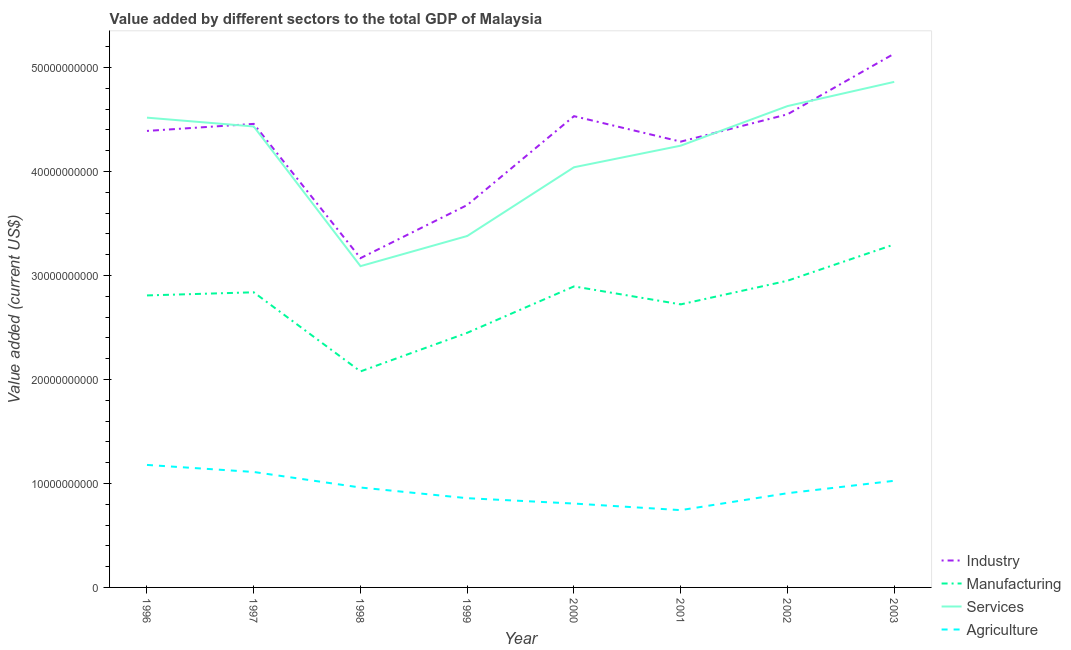Does the line corresponding to value added by industrial sector intersect with the line corresponding to value added by agricultural sector?
Offer a terse response. No. What is the value added by agricultural sector in 2002?
Keep it short and to the point. 9.06e+09. Across all years, what is the maximum value added by services sector?
Give a very brief answer. 4.86e+1. Across all years, what is the minimum value added by services sector?
Your response must be concise. 3.09e+1. In which year was the value added by services sector minimum?
Make the answer very short. 1998. What is the total value added by industrial sector in the graph?
Keep it short and to the point. 3.42e+11. What is the difference between the value added by industrial sector in 1997 and that in 2000?
Your answer should be compact. -7.43e+08. What is the difference between the value added by agricultural sector in 2002 and the value added by services sector in 1997?
Your answer should be very brief. -3.53e+1. What is the average value added by manufacturing sector per year?
Ensure brevity in your answer.  2.75e+1. In the year 1997, what is the difference between the value added by industrial sector and value added by manufacturing sector?
Make the answer very short. 1.62e+1. In how many years, is the value added by agricultural sector greater than 28000000000 US$?
Offer a very short reply. 0. What is the ratio of the value added by agricultural sector in 2000 to that in 2002?
Provide a short and direct response. 0.89. Is the value added by manufacturing sector in 1999 less than that in 2000?
Your answer should be compact. Yes. Is the difference between the value added by industrial sector in 2000 and 2001 greater than the difference between the value added by agricultural sector in 2000 and 2001?
Provide a succinct answer. Yes. What is the difference between the highest and the second highest value added by manufacturing sector?
Give a very brief answer. 3.49e+09. What is the difference between the highest and the lowest value added by industrial sector?
Ensure brevity in your answer.  1.97e+1. In how many years, is the value added by agricultural sector greater than the average value added by agricultural sector taken over all years?
Offer a very short reply. 4. Does the value added by industrial sector monotonically increase over the years?
Ensure brevity in your answer.  No. Is the value added by manufacturing sector strictly less than the value added by services sector over the years?
Your answer should be compact. Yes. How many years are there in the graph?
Make the answer very short. 8. Are the values on the major ticks of Y-axis written in scientific E-notation?
Offer a very short reply. No. Does the graph contain any zero values?
Your answer should be very brief. No. Where does the legend appear in the graph?
Give a very brief answer. Bottom right. How are the legend labels stacked?
Offer a terse response. Vertical. What is the title of the graph?
Your answer should be compact. Value added by different sectors to the total GDP of Malaysia. What is the label or title of the X-axis?
Offer a terse response. Year. What is the label or title of the Y-axis?
Your answer should be very brief. Value added (current US$). What is the Value added (current US$) in Industry in 1996?
Ensure brevity in your answer.  4.39e+1. What is the Value added (current US$) in Manufacturing in 1996?
Your answer should be very brief. 2.81e+1. What is the Value added (current US$) in Services in 1996?
Give a very brief answer. 4.52e+1. What is the Value added (current US$) of Agriculture in 1996?
Give a very brief answer. 1.18e+1. What is the Value added (current US$) of Industry in 1997?
Your answer should be compact. 4.46e+1. What is the Value added (current US$) in Manufacturing in 1997?
Offer a terse response. 2.84e+1. What is the Value added (current US$) in Services in 1997?
Provide a short and direct response. 4.43e+1. What is the Value added (current US$) of Agriculture in 1997?
Offer a very short reply. 1.11e+1. What is the Value added (current US$) in Industry in 1998?
Provide a succinct answer. 3.17e+1. What is the Value added (current US$) of Manufacturing in 1998?
Offer a terse response. 2.08e+1. What is the Value added (current US$) of Services in 1998?
Your answer should be compact. 3.09e+1. What is the Value added (current US$) in Agriculture in 1998?
Make the answer very short. 9.61e+09. What is the Value added (current US$) of Industry in 1999?
Make the answer very short. 3.68e+1. What is the Value added (current US$) of Manufacturing in 1999?
Make the answer very short. 2.45e+1. What is the Value added (current US$) of Services in 1999?
Your answer should be compact. 3.38e+1. What is the Value added (current US$) of Agriculture in 1999?
Offer a very short reply. 8.58e+09. What is the Value added (current US$) of Industry in 2000?
Offer a very short reply. 4.53e+1. What is the Value added (current US$) of Manufacturing in 2000?
Your answer should be very brief. 2.89e+1. What is the Value added (current US$) in Services in 2000?
Your answer should be very brief. 4.04e+1. What is the Value added (current US$) of Agriculture in 2000?
Your answer should be compact. 8.07e+09. What is the Value added (current US$) in Industry in 2001?
Give a very brief answer. 4.29e+1. What is the Value added (current US$) in Manufacturing in 2001?
Your answer should be very brief. 2.72e+1. What is the Value added (current US$) of Services in 2001?
Offer a terse response. 4.25e+1. What is the Value added (current US$) in Agriculture in 2001?
Make the answer very short. 7.43e+09. What is the Value added (current US$) of Industry in 2002?
Ensure brevity in your answer.  4.55e+1. What is the Value added (current US$) of Manufacturing in 2002?
Provide a short and direct response. 2.95e+1. What is the Value added (current US$) of Services in 2002?
Offer a very short reply. 4.63e+1. What is the Value added (current US$) in Agriculture in 2002?
Make the answer very short. 9.06e+09. What is the Value added (current US$) of Industry in 2003?
Provide a succinct answer. 5.13e+1. What is the Value added (current US$) in Manufacturing in 2003?
Your answer should be compact. 3.30e+1. What is the Value added (current US$) in Services in 2003?
Offer a very short reply. 4.86e+1. What is the Value added (current US$) of Agriculture in 2003?
Your answer should be compact. 1.03e+1. Across all years, what is the maximum Value added (current US$) of Industry?
Your response must be concise. 5.13e+1. Across all years, what is the maximum Value added (current US$) in Manufacturing?
Your response must be concise. 3.30e+1. Across all years, what is the maximum Value added (current US$) of Services?
Give a very brief answer. 4.86e+1. Across all years, what is the maximum Value added (current US$) in Agriculture?
Provide a succinct answer. 1.18e+1. Across all years, what is the minimum Value added (current US$) in Industry?
Make the answer very short. 3.17e+1. Across all years, what is the minimum Value added (current US$) in Manufacturing?
Ensure brevity in your answer.  2.08e+1. Across all years, what is the minimum Value added (current US$) in Services?
Your answer should be very brief. 3.09e+1. Across all years, what is the minimum Value added (current US$) of Agriculture?
Keep it short and to the point. 7.43e+09. What is the total Value added (current US$) of Industry in the graph?
Your response must be concise. 3.42e+11. What is the total Value added (current US$) of Manufacturing in the graph?
Keep it short and to the point. 2.20e+11. What is the total Value added (current US$) in Services in the graph?
Offer a very short reply. 3.32e+11. What is the total Value added (current US$) of Agriculture in the graph?
Keep it short and to the point. 7.59e+1. What is the difference between the Value added (current US$) of Industry in 1996 and that in 1997?
Your answer should be compact. -6.77e+08. What is the difference between the Value added (current US$) in Manufacturing in 1996 and that in 1997?
Offer a very short reply. -3.01e+08. What is the difference between the Value added (current US$) of Services in 1996 and that in 1997?
Make the answer very short. 8.48e+08. What is the difference between the Value added (current US$) in Agriculture in 1996 and that in 1997?
Make the answer very short. 6.78e+08. What is the difference between the Value added (current US$) in Industry in 1996 and that in 1998?
Your response must be concise. 1.22e+1. What is the difference between the Value added (current US$) of Manufacturing in 1996 and that in 1998?
Keep it short and to the point. 7.31e+09. What is the difference between the Value added (current US$) in Services in 1996 and that in 1998?
Your answer should be very brief. 1.43e+1. What is the difference between the Value added (current US$) in Agriculture in 1996 and that in 1998?
Offer a terse response. 2.17e+09. What is the difference between the Value added (current US$) of Industry in 1996 and that in 1999?
Offer a very short reply. 7.13e+09. What is the difference between the Value added (current US$) in Manufacturing in 1996 and that in 1999?
Your response must be concise. 3.60e+09. What is the difference between the Value added (current US$) of Services in 1996 and that in 1999?
Offer a terse response. 1.14e+1. What is the difference between the Value added (current US$) of Agriculture in 1996 and that in 1999?
Your answer should be very brief. 3.20e+09. What is the difference between the Value added (current US$) of Industry in 1996 and that in 2000?
Provide a succinct answer. -1.42e+09. What is the difference between the Value added (current US$) in Manufacturing in 1996 and that in 2000?
Ensure brevity in your answer.  -8.66e+08. What is the difference between the Value added (current US$) of Services in 1996 and that in 2000?
Make the answer very short. 4.77e+09. What is the difference between the Value added (current US$) of Agriculture in 1996 and that in 2000?
Offer a very short reply. 3.72e+09. What is the difference between the Value added (current US$) in Industry in 1996 and that in 2001?
Ensure brevity in your answer.  1.03e+09. What is the difference between the Value added (current US$) of Manufacturing in 1996 and that in 2001?
Your answer should be very brief. 8.61e+08. What is the difference between the Value added (current US$) in Services in 1996 and that in 2001?
Keep it short and to the point. 2.69e+09. What is the difference between the Value added (current US$) of Agriculture in 1996 and that in 2001?
Provide a succinct answer. 4.35e+09. What is the difference between the Value added (current US$) in Industry in 1996 and that in 2002?
Offer a terse response. -1.60e+09. What is the difference between the Value added (current US$) of Manufacturing in 1996 and that in 2002?
Your answer should be very brief. -1.41e+09. What is the difference between the Value added (current US$) in Services in 1996 and that in 2002?
Offer a terse response. -1.11e+09. What is the difference between the Value added (current US$) of Agriculture in 1996 and that in 2002?
Your response must be concise. 2.72e+09. What is the difference between the Value added (current US$) in Industry in 1996 and that in 2003?
Keep it short and to the point. -7.43e+09. What is the difference between the Value added (current US$) in Manufacturing in 1996 and that in 2003?
Your answer should be very brief. -4.90e+09. What is the difference between the Value added (current US$) of Services in 1996 and that in 2003?
Give a very brief answer. -3.44e+09. What is the difference between the Value added (current US$) in Agriculture in 1996 and that in 2003?
Offer a very short reply. 1.52e+09. What is the difference between the Value added (current US$) in Industry in 1997 and that in 1998?
Offer a very short reply. 1.29e+1. What is the difference between the Value added (current US$) of Manufacturing in 1997 and that in 1998?
Offer a very short reply. 7.61e+09. What is the difference between the Value added (current US$) of Services in 1997 and that in 1998?
Provide a succinct answer. 1.34e+1. What is the difference between the Value added (current US$) in Agriculture in 1997 and that in 1998?
Give a very brief answer. 1.49e+09. What is the difference between the Value added (current US$) in Industry in 1997 and that in 1999?
Give a very brief answer. 7.80e+09. What is the difference between the Value added (current US$) in Manufacturing in 1997 and that in 1999?
Offer a terse response. 3.90e+09. What is the difference between the Value added (current US$) of Services in 1997 and that in 1999?
Offer a terse response. 1.05e+1. What is the difference between the Value added (current US$) of Agriculture in 1997 and that in 1999?
Your answer should be compact. 2.52e+09. What is the difference between the Value added (current US$) of Industry in 1997 and that in 2000?
Make the answer very short. -7.43e+08. What is the difference between the Value added (current US$) of Manufacturing in 1997 and that in 2000?
Provide a succinct answer. -5.65e+08. What is the difference between the Value added (current US$) of Services in 1997 and that in 2000?
Your answer should be compact. 3.92e+09. What is the difference between the Value added (current US$) in Agriculture in 1997 and that in 2000?
Make the answer very short. 3.04e+09. What is the difference between the Value added (current US$) of Industry in 1997 and that in 2001?
Provide a succinct answer. 1.71e+09. What is the difference between the Value added (current US$) in Manufacturing in 1997 and that in 2001?
Offer a terse response. 1.16e+09. What is the difference between the Value added (current US$) of Services in 1997 and that in 2001?
Provide a short and direct response. 1.85e+09. What is the difference between the Value added (current US$) of Agriculture in 1997 and that in 2001?
Offer a terse response. 3.67e+09. What is the difference between the Value added (current US$) of Industry in 1997 and that in 2002?
Your answer should be compact. -9.21e+08. What is the difference between the Value added (current US$) in Manufacturing in 1997 and that in 2002?
Your answer should be compact. -1.11e+09. What is the difference between the Value added (current US$) of Services in 1997 and that in 2002?
Make the answer very short. -1.96e+09. What is the difference between the Value added (current US$) of Agriculture in 1997 and that in 2002?
Your response must be concise. 2.04e+09. What is the difference between the Value added (current US$) of Industry in 1997 and that in 2003?
Provide a short and direct response. -6.75e+09. What is the difference between the Value added (current US$) of Manufacturing in 1997 and that in 2003?
Keep it short and to the point. -4.60e+09. What is the difference between the Value added (current US$) of Services in 1997 and that in 2003?
Give a very brief answer. -4.29e+09. What is the difference between the Value added (current US$) in Agriculture in 1997 and that in 2003?
Your answer should be compact. 8.47e+08. What is the difference between the Value added (current US$) in Industry in 1998 and that in 1999?
Your answer should be very brief. -5.11e+09. What is the difference between the Value added (current US$) of Manufacturing in 1998 and that in 1999?
Your answer should be very brief. -3.71e+09. What is the difference between the Value added (current US$) of Services in 1998 and that in 1999?
Make the answer very short. -2.90e+09. What is the difference between the Value added (current US$) in Agriculture in 1998 and that in 1999?
Your answer should be very brief. 1.03e+09. What is the difference between the Value added (current US$) in Industry in 1998 and that in 2000?
Your answer should be compact. -1.37e+1. What is the difference between the Value added (current US$) of Manufacturing in 1998 and that in 2000?
Give a very brief answer. -8.18e+09. What is the difference between the Value added (current US$) of Services in 1998 and that in 2000?
Offer a terse response. -9.51e+09. What is the difference between the Value added (current US$) in Agriculture in 1998 and that in 2000?
Provide a short and direct response. 1.54e+09. What is the difference between the Value added (current US$) of Industry in 1998 and that in 2001?
Your response must be concise. -1.12e+1. What is the difference between the Value added (current US$) in Manufacturing in 1998 and that in 2001?
Your answer should be compact. -6.45e+09. What is the difference between the Value added (current US$) of Services in 1998 and that in 2001?
Give a very brief answer. -1.16e+1. What is the difference between the Value added (current US$) in Agriculture in 1998 and that in 2001?
Provide a short and direct response. 2.17e+09. What is the difference between the Value added (current US$) of Industry in 1998 and that in 2002?
Ensure brevity in your answer.  -1.38e+1. What is the difference between the Value added (current US$) in Manufacturing in 1998 and that in 2002?
Your response must be concise. -8.72e+09. What is the difference between the Value added (current US$) of Services in 1998 and that in 2002?
Provide a succinct answer. -1.54e+1. What is the difference between the Value added (current US$) in Agriculture in 1998 and that in 2002?
Give a very brief answer. 5.47e+08. What is the difference between the Value added (current US$) of Industry in 1998 and that in 2003?
Offer a terse response. -1.97e+1. What is the difference between the Value added (current US$) in Manufacturing in 1998 and that in 2003?
Offer a terse response. -1.22e+1. What is the difference between the Value added (current US$) of Services in 1998 and that in 2003?
Offer a very short reply. -1.77e+1. What is the difference between the Value added (current US$) of Agriculture in 1998 and that in 2003?
Your response must be concise. -6.48e+08. What is the difference between the Value added (current US$) in Industry in 1999 and that in 2000?
Ensure brevity in your answer.  -8.55e+09. What is the difference between the Value added (current US$) of Manufacturing in 1999 and that in 2000?
Give a very brief answer. -4.46e+09. What is the difference between the Value added (current US$) of Services in 1999 and that in 2000?
Offer a very short reply. -6.61e+09. What is the difference between the Value added (current US$) in Agriculture in 1999 and that in 2000?
Provide a short and direct response. 5.16e+08. What is the difference between the Value added (current US$) in Industry in 1999 and that in 2001?
Give a very brief answer. -6.10e+09. What is the difference between the Value added (current US$) of Manufacturing in 1999 and that in 2001?
Make the answer very short. -2.73e+09. What is the difference between the Value added (current US$) of Services in 1999 and that in 2001?
Keep it short and to the point. -8.69e+09. What is the difference between the Value added (current US$) of Agriculture in 1999 and that in 2001?
Provide a short and direct response. 1.15e+09. What is the difference between the Value added (current US$) of Industry in 1999 and that in 2002?
Offer a terse response. -8.72e+09. What is the difference between the Value added (current US$) of Manufacturing in 1999 and that in 2002?
Give a very brief answer. -5.01e+09. What is the difference between the Value added (current US$) of Services in 1999 and that in 2002?
Offer a very short reply. -1.25e+1. What is the difference between the Value added (current US$) of Agriculture in 1999 and that in 2002?
Your answer should be compact. -4.79e+08. What is the difference between the Value added (current US$) in Industry in 1999 and that in 2003?
Make the answer very short. -1.46e+1. What is the difference between the Value added (current US$) in Manufacturing in 1999 and that in 2003?
Provide a succinct answer. -8.50e+09. What is the difference between the Value added (current US$) in Services in 1999 and that in 2003?
Ensure brevity in your answer.  -1.48e+1. What is the difference between the Value added (current US$) of Agriculture in 1999 and that in 2003?
Provide a succinct answer. -1.67e+09. What is the difference between the Value added (current US$) of Industry in 2000 and that in 2001?
Keep it short and to the point. 2.45e+09. What is the difference between the Value added (current US$) in Manufacturing in 2000 and that in 2001?
Ensure brevity in your answer.  1.73e+09. What is the difference between the Value added (current US$) in Services in 2000 and that in 2001?
Provide a short and direct response. -2.08e+09. What is the difference between the Value added (current US$) in Agriculture in 2000 and that in 2001?
Offer a very short reply. 6.32e+08. What is the difference between the Value added (current US$) of Industry in 2000 and that in 2002?
Make the answer very short. -1.78e+08. What is the difference between the Value added (current US$) of Manufacturing in 2000 and that in 2002?
Your answer should be compact. -5.47e+08. What is the difference between the Value added (current US$) of Services in 2000 and that in 2002?
Offer a very short reply. -5.88e+09. What is the difference between the Value added (current US$) of Agriculture in 2000 and that in 2002?
Your answer should be very brief. -9.96e+08. What is the difference between the Value added (current US$) of Industry in 2000 and that in 2003?
Offer a terse response. -6.01e+09. What is the difference between the Value added (current US$) in Manufacturing in 2000 and that in 2003?
Provide a succinct answer. -4.04e+09. What is the difference between the Value added (current US$) in Services in 2000 and that in 2003?
Provide a short and direct response. -8.21e+09. What is the difference between the Value added (current US$) of Agriculture in 2000 and that in 2003?
Your answer should be compact. -2.19e+09. What is the difference between the Value added (current US$) in Industry in 2001 and that in 2002?
Your answer should be very brief. -2.63e+09. What is the difference between the Value added (current US$) in Manufacturing in 2001 and that in 2002?
Give a very brief answer. -2.27e+09. What is the difference between the Value added (current US$) of Services in 2001 and that in 2002?
Your answer should be very brief. -3.81e+09. What is the difference between the Value added (current US$) of Agriculture in 2001 and that in 2002?
Provide a succinct answer. -1.63e+09. What is the difference between the Value added (current US$) of Industry in 2001 and that in 2003?
Offer a terse response. -8.46e+09. What is the difference between the Value added (current US$) in Manufacturing in 2001 and that in 2003?
Your response must be concise. -5.76e+09. What is the difference between the Value added (current US$) of Services in 2001 and that in 2003?
Give a very brief answer. -6.13e+09. What is the difference between the Value added (current US$) of Agriculture in 2001 and that in 2003?
Make the answer very short. -2.82e+09. What is the difference between the Value added (current US$) of Industry in 2002 and that in 2003?
Your answer should be very brief. -5.83e+09. What is the difference between the Value added (current US$) in Manufacturing in 2002 and that in 2003?
Make the answer very short. -3.49e+09. What is the difference between the Value added (current US$) of Services in 2002 and that in 2003?
Keep it short and to the point. -2.33e+09. What is the difference between the Value added (current US$) of Agriculture in 2002 and that in 2003?
Offer a very short reply. -1.19e+09. What is the difference between the Value added (current US$) of Industry in 1996 and the Value added (current US$) of Manufacturing in 1997?
Your response must be concise. 1.55e+1. What is the difference between the Value added (current US$) of Industry in 1996 and the Value added (current US$) of Services in 1997?
Offer a very short reply. -4.28e+08. What is the difference between the Value added (current US$) of Industry in 1996 and the Value added (current US$) of Agriculture in 1997?
Keep it short and to the point. 3.28e+1. What is the difference between the Value added (current US$) of Manufacturing in 1996 and the Value added (current US$) of Services in 1997?
Give a very brief answer. -1.62e+1. What is the difference between the Value added (current US$) of Manufacturing in 1996 and the Value added (current US$) of Agriculture in 1997?
Your response must be concise. 1.70e+1. What is the difference between the Value added (current US$) of Services in 1996 and the Value added (current US$) of Agriculture in 1997?
Your answer should be very brief. 3.41e+1. What is the difference between the Value added (current US$) of Industry in 1996 and the Value added (current US$) of Manufacturing in 1998?
Provide a short and direct response. 2.31e+1. What is the difference between the Value added (current US$) in Industry in 1996 and the Value added (current US$) in Services in 1998?
Your response must be concise. 1.30e+1. What is the difference between the Value added (current US$) in Industry in 1996 and the Value added (current US$) in Agriculture in 1998?
Your response must be concise. 3.43e+1. What is the difference between the Value added (current US$) of Manufacturing in 1996 and the Value added (current US$) of Services in 1998?
Your answer should be very brief. -2.81e+09. What is the difference between the Value added (current US$) in Manufacturing in 1996 and the Value added (current US$) in Agriculture in 1998?
Give a very brief answer. 1.85e+1. What is the difference between the Value added (current US$) of Services in 1996 and the Value added (current US$) of Agriculture in 1998?
Your answer should be compact. 3.56e+1. What is the difference between the Value added (current US$) of Industry in 1996 and the Value added (current US$) of Manufacturing in 1999?
Your answer should be compact. 1.94e+1. What is the difference between the Value added (current US$) of Industry in 1996 and the Value added (current US$) of Services in 1999?
Your response must be concise. 1.01e+1. What is the difference between the Value added (current US$) of Industry in 1996 and the Value added (current US$) of Agriculture in 1999?
Your response must be concise. 3.53e+1. What is the difference between the Value added (current US$) in Manufacturing in 1996 and the Value added (current US$) in Services in 1999?
Give a very brief answer. -5.71e+09. What is the difference between the Value added (current US$) of Manufacturing in 1996 and the Value added (current US$) of Agriculture in 1999?
Offer a terse response. 1.95e+1. What is the difference between the Value added (current US$) in Services in 1996 and the Value added (current US$) in Agriculture in 1999?
Offer a terse response. 3.66e+1. What is the difference between the Value added (current US$) of Industry in 1996 and the Value added (current US$) of Manufacturing in 2000?
Your answer should be compact. 1.50e+1. What is the difference between the Value added (current US$) in Industry in 1996 and the Value added (current US$) in Services in 2000?
Your response must be concise. 3.49e+09. What is the difference between the Value added (current US$) of Industry in 1996 and the Value added (current US$) of Agriculture in 2000?
Give a very brief answer. 3.58e+1. What is the difference between the Value added (current US$) of Manufacturing in 1996 and the Value added (current US$) of Services in 2000?
Your response must be concise. -1.23e+1. What is the difference between the Value added (current US$) in Manufacturing in 1996 and the Value added (current US$) in Agriculture in 2000?
Give a very brief answer. 2.00e+1. What is the difference between the Value added (current US$) of Services in 1996 and the Value added (current US$) of Agriculture in 2000?
Keep it short and to the point. 3.71e+1. What is the difference between the Value added (current US$) in Industry in 1996 and the Value added (current US$) in Manufacturing in 2001?
Provide a succinct answer. 1.67e+1. What is the difference between the Value added (current US$) in Industry in 1996 and the Value added (current US$) in Services in 2001?
Keep it short and to the point. 1.42e+09. What is the difference between the Value added (current US$) in Industry in 1996 and the Value added (current US$) in Agriculture in 2001?
Your answer should be compact. 3.65e+1. What is the difference between the Value added (current US$) in Manufacturing in 1996 and the Value added (current US$) in Services in 2001?
Give a very brief answer. -1.44e+1. What is the difference between the Value added (current US$) in Manufacturing in 1996 and the Value added (current US$) in Agriculture in 2001?
Provide a succinct answer. 2.06e+1. What is the difference between the Value added (current US$) in Services in 1996 and the Value added (current US$) in Agriculture in 2001?
Offer a very short reply. 3.77e+1. What is the difference between the Value added (current US$) in Industry in 1996 and the Value added (current US$) in Manufacturing in 2002?
Provide a succinct answer. 1.44e+1. What is the difference between the Value added (current US$) of Industry in 1996 and the Value added (current US$) of Services in 2002?
Provide a short and direct response. -2.39e+09. What is the difference between the Value added (current US$) in Industry in 1996 and the Value added (current US$) in Agriculture in 2002?
Your response must be concise. 3.48e+1. What is the difference between the Value added (current US$) in Manufacturing in 1996 and the Value added (current US$) in Services in 2002?
Your answer should be very brief. -1.82e+1. What is the difference between the Value added (current US$) in Manufacturing in 1996 and the Value added (current US$) in Agriculture in 2002?
Give a very brief answer. 1.90e+1. What is the difference between the Value added (current US$) in Services in 1996 and the Value added (current US$) in Agriculture in 2002?
Your answer should be very brief. 3.61e+1. What is the difference between the Value added (current US$) of Industry in 1996 and the Value added (current US$) of Manufacturing in 2003?
Your response must be concise. 1.09e+1. What is the difference between the Value added (current US$) of Industry in 1996 and the Value added (current US$) of Services in 2003?
Your answer should be very brief. -4.72e+09. What is the difference between the Value added (current US$) in Industry in 1996 and the Value added (current US$) in Agriculture in 2003?
Offer a terse response. 3.36e+1. What is the difference between the Value added (current US$) of Manufacturing in 1996 and the Value added (current US$) of Services in 2003?
Make the answer very short. -2.05e+1. What is the difference between the Value added (current US$) in Manufacturing in 1996 and the Value added (current US$) in Agriculture in 2003?
Provide a succinct answer. 1.78e+1. What is the difference between the Value added (current US$) in Services in 1996 and the Value added (current US$) in Agriculture in 2003?
Your response must be concise. 3.49e+1. What is the difference between the Value added (current US$) of Industry in 1997 and the Value added (current US$) of Manufacturing in 1998?
Ensure brevity in your answer.  2.38e+1. What is the difference between the Value added (current US$) in Industry in 1997 and the Value added (current US$) in Services in 1998?
Provide a succinct answer. 1.37e+1. What is the difference between the Value added (current US$) in Industry in 1997 and the Value added (current US$) in Agriculture in 1998?
Ensure brevity in your answer.  3.50e+1. What is the difference between the Value added (current US$) of Manufacturing in 1997 and the Value added (current US$) of Services in 1998?
Keep it short and to the point. -2.51e+09. What is the difference between the Value added (current US$) in Manufacturing in 1997 and the Value added (current US$) in Agriculture in 1998?
Offer a terse response. 1.88e+1. What is the difference between the Value added (current US$) in Services in 1997 and the Value added (current US$) in Agriculture in 1998?
Ensure brevity in your answer.  3.47e+1. What is the difference between the Value added (current US$) of Industry in 1997 and the Value added (current US$) of Manufacturing in 1999?
Offer a very short reply. 2.01e+1. What is the difference between the Value added (current US$) of Industry in 1997 and the Value added (current US$) of Services in 1999?
Make the answer very short. 1.08e+1. What is the difference between the Value added (current US$) in Industry in 1997 and the Value added (current US$) in Agriculture in 1999?
Give a very brief answer. 3.60e+1. What is the difference between the Value added (current US$) in Manufacturing in 1997 and the Value added (current US$) in Services in 1999?
Make the answer very short. -5.41e+09. What is the difference between the Value added (current US$) in Manufacturing in 1997 and the Value added (current US$) in Agriculture in 1999?
Ensure brevity in your answer.  1.98e+1. What is the difference between the Value added (current US$) in Services in 1997 and the Value added (current US$) in Agriculture in 1999?
Your answer should be compact. 3.57e+1. What is the difference between the Value added (current US$) in Industry in 1997 and the Value added (current US$) in Manufacturing in 2000?
Your answer should be very brief. 1.56e+1. What is the difference between the Value added (current US$) of Industry in 1997 and the Value added (current US$) of Services in 2000?
Offer a terse response. 4.17e+09. What is the difference between the Value added (current US$) of Industry in 1997 and the Value added (current US$) of Agriculture in 2000?
Your response must be concise. 3.65e+1. What is the difference between the Value added (current US$) in Manufacturing in 1997 and the Value added (current US$) in Services in 2000?
Offer a terse response. -1.20e+1. What is the difference between the Value added (current US$) in Manufacturing in 1997 and the Value added (current US$) in Agriculture in 2000?
Your answer should be very brief. 2.03e+1. What is the difference between the Value added (current US$) in Services in 1997 and the Value added (current US$) in Agriculture in 2000?
Your response must be concise. 3.63e+1. What is the difference between the Value added (current US$) of Industry in 1997 and the Value added (current US$) of Manufacturing in 2001?
Keep it short and to the point. 1.74e+1. What is the difference between the Value added (current US$) in Industry in 1997 and the Value added (current US$) in Services in 2001?
Ensure brevity in your answer.  2.09e+09. What is the difference between the Value added (current US$) of Industry in 1997 and the Value added (current US$) of Agriculture in 2001?
Offer a terse response. 3.71e+1. What is the difference between the Value added (current US$) of Manufacturing in 1997 and the Value added (current US$) of Services in 2001?
Ensure brevity in your answer.  -1.41e+1. What is the difference between the Value added (current US$) of Manufacturing in 1997 and the Value added (current US$) of Agriculture in 2001?
Your response must be concise. 2.09e+1. What is the difference between the Value added (current US$) of Services in 1997 and the Value added (current US$) of Agriculture in 2001?
Offer a very short reply. 3.69e+1. What is the difference between the Value added (current US$) of Industry in 1997 and the Value added (current US$) of Manufacturing in 2002?
Provide a short and direct response. 1.51e+1. What is the difference between the Value added (current US$) in Industry in 1997 and the Value added (current US$) in Services in 2002?
Keep it short and to the point. -1.71e+09. What is the difference between the Value added (current US$) of Industry in 1997 and the Value added (current US$) of Agriculture in 2002?
Keep it short and to the point. 3.55e+1. What is the difference between the Value added (current US$) of Manufacturing in 1997 and the Value added (current US$) of Services in 2002?
Ensure brevity in your answer.  -1.79e+1. What is the difference between the Value added (current US$) of Manufacturing in 1997 and the Value added (current US$) of Agriculture in 2002?
Your response must be concise. 1.93e+1. What is the difference between the Value added (current US$) in Services in 1997 and the Value added (current US$) in Agriculture in 2002?
Ensure brevity in your answer.  3.53e+1. What is the difference between the Value added (current US$) in Industry in 1997 and the Value added (current US$) in Manufacturing in 2003?
Provide a short and direct response. 1.16e+1. What is the difference between the Value added (current US$) of Industry in 1997 and the Value added (current US$) of Services in 2003?
Your answer should be compact. -4.04e+09. What is the difference between the Value added (current US$) in Industry in 1997 and the Value added (current US$) in Agriculture in 2003?
Your answer should be very brief. 3.43e+1. What is the difference between the Value added (current US$) in Manufacturing in 1997 and the Value added (current US$) in Services in 2003?
Give a very brief answer. -2.02e+1. What is the difference between the Value added (current US$) of Manufacturing in 1997 and the Value added (current US$) of Agriculture in 2003?
Offer a very short reply. 1.81e+1. What is the difference between the Value added (current US$) of Services in 1997 and the Value added (current US$) of Agriculture in 2003?
Give a very brief answer. 3.41e+1. What is the difference between the Value added (current US$) in Industry in 1998 and the Value added (current US$) in Manufacturing in 1999?
Offer a terse response. 7.18e+09. What is the difference between the Value added (current US$) in Industry in 1998 and the Value added (current US$) in Services in 1999?
Keep it short and to the point. -2.13e+09. What is the difference between the Value added (current US$) in Industry in 1998 and the Value added (current US$) in Agriculture in 1999?
Give a very brief answer. 2.31e+1. What is the difference between the Value added (current US$) in Manufacturing in 1998 and the Value added (current US$) in Services in 1999?
Your answer should be compact. -1.30e+1. What is the difference between the Value added (current US$) of Manufacturing in 1998 and the Value added (current US$) of Agriculture in 1999?
Provide a succinct answer. 1.22e+1. What is the difference between the Value added (current US$) in Services in 1998 and the Value added (current US$) in Agriculture in 1999?
Give a very brief answer. 2.23e+1. What is the difference between the Value added (current US$) of Industry in 1998 and the Value added (current US$) of Manufacturing in 2000?
Your response must be concise. 2.72e+09. What is the difference between the Value added (current US$) of Industry in 1998 and the Value added (current US$) of Services in 2000?
Offer a very short reply. -8.74e+09. What is the difference between the Value added (current US$) in Industry in 1998 and the Value added (current US$) in Agriculture in 2000?
Ensure brevity in your answer.  2.36e+1. What is the difference between the Value added (current US$) of Manufacturing in 1998 and the Value added (current US$) of Services in 2000?
Keep it short and to the point. -1.96e+1. What is the difference between the Value added (current US$) in Manufacturing in 1998 and the Value added (current US$) in Agriculture in 2000?
Offer a very short reply. 1.27e+1. What is the difference between the Value added (current US$) in Services in 1998 and the Value added (current US$) in Agriculture in 2000?
Offer a terse response. 2.28e+1. What is the difference between the Value added (current US$) in Industry in 1998 and the Value added (current US$) in Manufacturing in 2001?
Offer a very short reply. 4.45e+09. What is the difference between the Value added (current US$) in Industry in 1998 and the Value added (current US$) in Services in 2001?
Offer a terse response. -1.08e+1. What is the difference between the Value added (current US$) in Industry in 1998 and the Value added (current US$) in Agriculture in 2001?
Ensure brevity in your answer.  2.42e+1. What is the difference between the Value added (current US$) of Manufacturing in 1998 and the Value added (current US$) of Services in 2001?
Offer a very short reply. -2.17e+1. What is the difference between the Value added (current US$) of Manufacturing in 1998 and the Value added (current US$) of Agriculture in 2001?
Your answer should be compact. 1.33e+1. What is the difference between the Value added (current US$) in Services in 1998 and the Value added (current US$) in Agriculture in 2001?
Ensure brevity in your answer.  2.35e+1. What is the difference between the Value added (current US$) in Industry in 1998 and the Value added (current US$) in Manufacturing in 2002?
Your answer should be compact. 2.17e+09. What is the difference between the Value added (current US$) in Industry in 1998 and the Value added (current US$) in Services in 2002?
Give a very brief answer. -1.46e+1. What is the difference between the Value added (current US$) in Industry in 1998 and the Value added (current US$) in Agriculture in 2002?
Provide a short and direct response. 2.26e+1. What is the difference between the Value added (current US$) in Manufacturing in 1998 and the Value added (current US$) in Services in 2002?
Give a very brief answer. -2.55e+1. What is the difference between the Value added (current US$) in Manufacturing in 1998 and the Value added (current US$) in Agriculture in 2002?
Offer a very short reply. 1.17e+1. What is the difference between the Value added (current US$) in Services in 1998 and the Value added (current US$) in Agriculture in 2002?
Give a very brief answer. 2.18e+1. What is the difference between the Value added (current US$) in Industry in 1998 and the Value added (current US$) in Manufacturing in 2003?
Give a very brief answer. -1.32e+09. What is the difference between the Value added (current US$) of Industry in 1998 and the Value added (current US$) of Services in 2003?
Offer a terse response. -1.70e+1. What is the difference between the Value added (current US$) of Industry in 1998 and the Value added (current US$) of Agriculture in 2003?
Provide a succinct answer. 2.14e+1. What is the difference between the Value added (current US$) of Manufacturing in 1998 and the Value added (current US$) of Services in 2003?
Offer a terse response. -2.78e+1. What is the difference between the Value added (current US$) of Manufacturing in 1998 and the Value added (current US$) of Agriculture in 2003?
Offer a very short reply. 1.05e+1. What is the difference between the Value added (current US$) in Services in 1998 and the Value added (current US$) in Agriculture in 2003?
Keep it short and to the point. 2.06e+1. What is the difference between the Value added (current US$) of Industry in 1999 and the Value added (current US$) of Manufacturing in 2000?
Ensure brevity in your answer.  7.83e+09. What is the difference between the Value added (current US$) of Industry in 1999 and the Value added (current US$) of Services in 2000?
Give a very brief answer. -3.63e+09. What is the difference between the Value added (current US$) of Industry in 1999 and the Value added (current US$) of Agriculture in 2000?
Make the answer very short. 2.87e+1. What is the difference between the Value added (current US$) of Manufacturing in 1999 and the Value added (current US$) of Services in 2000?
Ensure brevity in your answer.  -1.59e+1. What is the difference between the Value added (current US$) of Manufacturing in 1999 and the Value added (current US$) of Agriculture in 2000?
Your response must be concise. 1.64e+1. What is the difference between the Value added (current US$) in Services in 1999 and the Value added (current US$) in Agriculture in 2000?
Make the answer very short. 2.57e+1. What is the difference between the Value added (current US$) of Industry in 1999 and the Value added (current US$) of Manufacturing in 2001?
Your answer should be compact. 9.55e+09. What is the difference between the Value added (current US$) of Industry in 1999 and the Value added (current US$) of Services in 2001?
Provide a succinct answer. -5.71e+09. What is the difference between the Value added (current US$) of Industry in 1999 and the Value added (current US$) of Agriculture in 2001?
Provide a succinct answer. 2.93e+1. What is the difference between the Value added (current US$) of Manufacturing in 1999 and the Value added (current US$) of Services in 2001?
Offer a terse response. -1.80e+1. What is the difference between the Value added (current US$) in Manufacturing in 1999 and the Value added (current US$) in Agriculture in 2001?
Your answer should be very brief. 1.71e+1. What is the difference between the Value added (current US$) in Services in 1999 and the Value added (current US$) in Agriculture in 2001?
Offer a very short reply. 2.64e+1. What is the difference between the Value added (current US$) in Industry in 1999 and the Value added (current US$) in Manufacturing in 2002?
Your response must be concise. 7.28e+09. What is the difference between the Value added (current US$) in Industry in 1999 and the Value added (current US$) in Services in 2002?
Ensure brevity in your answer.  -9.52e+09. What is the difference between the Value added (current US$) of Industry in 1999 and the Value added (current US$) of Agriculture in 2002?
Ensure brevity in your answer.  2.77e+1. What is the difference between the Value added (current US$) in Manufacturing in 1999 and the Value added (current US$) in Services in 2002?
Ensure brevity in your answer.  -2.18e+1. What is the difference between the Value added (current US$) of Manufacturing in 1999 and the Value added (current US$) of Agriculture in 2002?
Offer a terse response. 1.54e+1. What is the difference between the Value added (current US$) of Services in 1999 and the Value added (current US$) of Agriculture in 2002?
Your answer should be very brief. 2.47e+1. What is the difference between the Value added (current US$) of Industry in 1999 and the Value added (current US$) of Manufacturing in 2003?
Offer a terse response. 3.79e+09. What is the difference between the Value added (current US$) in Industry in 1999 and the Value added (current US$) in Services in 2003?
Provide a succinct answer. -1.18e+1. What is the difference between the Value added (current US$) in Industry in 1999 and the Value added (current US$) in Agriculture in 2003?
Your answer should be compact. 2.65e+1. What is the difference between the Value added (current US$) in Manufacturing in 1999 and the Value added (current US$) in Services in 2003?
Your answer should be compact. -2.41e+1. What is the difference between the Value added (current US$) of Manufacturing in 1999 and the Value added (current US$) of Agriculture in 2003?
Give a very brief answer. 1.42e+1. What is the difference between the Value added (current US$) of Services in 1999 and the Value added (current US$) of Agriculture in 2003?
Your response must be concise. 2.35e+1. What is the difference between the Value added (current US$) of Industry in 2000 and the Value added (current US$) of Manufacturing in 2001?
Provide a succinct answer. 1.81e+1. What is the difference between the Value added (current US$) of Industry in 2000 and the Value added (current US$) of Services in 2001?
Offer a terse response. 2.84e+09. What is the difference between the Value added (current US$) in Industry in 2000 and the Value added (current US$) in Agriculture in 2001?
Your answer should be compact. 3.79e+1. What is the difference between the Value added (current US$) in Manufacturing in 2000 and the Value added (current US$) in Services in 2001?
Keep it short and to the point. -1.35e+1. What is the difference between the Value added (current US$) in Manufacturing in 2000 and the Value added (current US$) in Agriculture in 2001?
Make the answer very short. 2.15e+1. What is the difference between the Value added (current US$) of Services in 2000 and the Value added (current US$) of Agriculture in 2001?
Provide a succinct answer. 3.30e+1. What is the difference between the Value added (current US$) of Industry in 2000 and the Value added (current US$) of Manufacturing in 2002?
Your response must be concise. 1.58e+1. What is the difference between the Value added (current US$) in Industry in 2000 and the Value added (current US$) in Services in 2002?
Offer a very short reply. -9.68e+08. What is the difference between the Value added (current US$) in Industry in 2000 and the Value added (current US$) in Agriculture in 2002?
Provide a succinct answer. 3.63e+1. What is the difference between the Value added (current US$) in Manufacturing in 2000 and the Value added (current US$) in Services in 2002?
Offer a terse response. -1.73e+1. What is the difference between the Value added (current US$) in Manufacturing in 2000 and the Value added (current US$) in Agriculture in 2002?
Offer a very short reply. 1.99e+1. What is the difference between the Value added (current US$) of Services in 2000 and the Value added (current US$) of Agriculture in 2002?
Offer a very short reply. 3.13e+1. What is the difference between the Value added (current US$) in Industry in 2000 and the Value added (current US$) in Manufacturing in 2003?
Ensure brevity in your answer.  1.23e+1. What is the difference between the Value added (current US$) of Industry in 2000 and the Value added (current US$) of Services in 2003?
Provide a short and direct response. -3.30e+09. What is the difference between the Value added (current US$) in Industry in 2000 and the Value added (current US$) in Agriculture in 2003?
Make the answer very short. 3.51e+1. What is the difference between the Value added (current US$) of Manufacturing in 2000 and the Value added (current US$) of Services in 2003?
Provide a short and direct response. -1.97e+1. What is the difference between the Value added (current US$) in Manufacturing in 2000 and the Value added (current US$) in Agriculture in 2003?
Provide a succinct answer. 1.87e+1. What is the difference between the Value added (current US$) of Services in 2000 and the Value added (current US$) of Agriculture in 2003?
Provide a short and direct response. 3.01e+1. What is the difference between the Value added (current US$) in Industry in 2001 and the Value added (current US$) in Manufacturing in 2002?
Offer a terse response. 1.34e+1. What is the difference between the Value added (current US$) in Industry in 2001 and the Value added (current US$) in Services in 2002?
Keep it short and to the point. -3.42e+09. What is the difference between the Value added (current US$) of Industry in 2001 and the Value added (current US$) of Agriculture in 2002?
Provide a succinct answer. 3.38e+1. What is the difference between the Value added (current US$) of Manufacturing in 2001 and the Value added (current US$) of Services in 2002?
Ensure brevity in your answer.  -1.91e+1. What is the difference between the Value added (current US$) in Manufacturing in 2001 and the Value added (current US$) in Agriculture in 2002?
Provide a succinct answer. 1.82e+1. What is the difference between the Value added (current US$) of Services in 2001 and the Value added (current US$) of Agriculture in 2002?
Provide a short and direct response. 3.34e+1. What is the difference between the Value added (current US$) in Industry in 2001 and the Value added (current US$) in Manufacturing in 2003?
Give a very brief answer. 9.89e+09. What is the difference between the Value added (current US$) in Industry in 2001 and the Value added (current US$) in Services in 2003?
Offer a very short reply. -5.75e+09. What is the difference between the Value added (current US$) of Industry in 2001 and the Value added (current US$) of Agriculture in 2003?
Offer a very short reply. 3.26e+1. What is the difference between the Value added (current US$) in Manufacturing in 2001 and the Value added (current US$) in Services in 2003?
Give a very brief answer. -2.14e+1. What is the difference between the Value added (current US$) of Manufacturing in 2001 and the Value added (current US$) of Agriculture in 2003?
Your answer should be compact. 1.70e+1. What is the difference between the Value added (current US$) of Services in 2001 and the Value added (current US$) of Agriculture in 2003?
Ensure brevity in your answer.  3.22e+1. What is the difference between the Value added (current US$) in Industry in 2002 and the Value added (current US$) in Manufacturing in 2003?
Ensure brevity in your answer.  1.25e+1. What is the difference between the Value added (current US$) of Industry in 2002 and the Value added (current US$) of Services in 2003?
Provide a succinct answer. -3.12e+09. What is the difference between the Value added (current US$) in Industry in 2002 and the Value added (current US$) in Agriculture in 2003?
Give a very brief answer. 3.52e+1. What is the difference between the Value added (current US$) of Manufacturing in 2002 and the Value added (current US$) of Services in 2003?
Your answer should be very brief. -1.91e+1. What is the difference between the Value added (current US$) of Manufacturing in 2002 and the Value added (current US$) of Agriculture in 2003?
Make the answer very short. 1.92e+1. What is the difference between the Value added (current US$) in Services in 2002 and the Value added (current US$) in Agriculture in 2003?
Provide a short and direct response. 3.60e+1. What is the average Value added (current US$) of Industry per year?
Offer a terse response. 4.27e+1. What is the average Value added (current US$) in Manufacturing per year?
Your answer should be compact. 2.75e+1. What is the average Value added (current US$) of Services per year?
Provide a succinct answer. 4.15e+1. What is the average Value added (current US$) in Agriculture per year?
Offer a terse response. 9.49e+09. In the year 1996, what is the difference between the Value added (current US$) in Industry and Value added (current US$) in Manufacturing?
Give a very brief answer. 1.58e+1. In the year 1996, what is the difference between the Value added (current US$) in Industry and Value added (current US$) in Services?
Make the answer very short. -1.28e+09. In the year 1996, what is the difference between the Value added (current US$) in Industry and Value added (current US$) in Agriculture?
Your answer should be very brief. 3.21e+1. In the year 1996, what is the difference between the Value added (current US$) of Manufacturing and Value added (current US$) of Services?
Keep it short and to the point. -1.71e+1. In the year 1996, what is the difference between the Value added (current US$) of Manufacturing and Value added (current US$) of Agriculture?
Offer a terse response. 1.63e+1. In the year 1996, what is the difference between the Value added (current US$) in Services and Value added (current US$) in Agriculture?
Your answer should be compact. 3.34e+1. In the year 1997, what is the difference between the Value added (current US$) of Industry and Value added (current US$) of Manufacturing?
Your answer should be very brief. 1.62e+1. In the year 1997, what is the difference between the Value added (current US$) in Industry and Value added (current US$) in Services?
Ensure brevity in your answer.  2.49e+08. In the year 1997, what is the difference between the Value added (current US$) in Industry and Value added (current US$) in Agriculture?
Your answer should be very brief. 3.35e+1. In the year 1997, what is the difference between the Value added (current US$) of Manufacturing and Value added (current US$) of Services?
Provide a succinct answer. -1.59e+1. In the year 1997, what is the difference between the Value added (current US$) of Manufacturing and Value added (current US$) of Agriculture?
Your answer should be very brief. 1.73e+1. In the year 1997, what is the difference between the Value added (current US$) of Services and Value added (current US$) of Agriculture?
Provide a short and direct response. 3.32e+1. In the year 1998, what is the difference between the Value added (current US$) in Industry and Value added (current US$) in Manufacturing?
Keep it short and to the point. 1.09e+1. In the year 1998, what is the difference between the Value added (current US$) in Industry and Value added (current US$) in Services?
Your response must be concise. 7.69e+08. In the year 1998, what is the difference between the Value added (current US$) of Industry and Value added (current US$) of Agriculture?
Keep it short and to the point. 2.21e+1. In the year 1998, what is the difference between the Value added (current US$) in Manufacturing and Value added (current US$) in Services?
Your answer should be very brief. -1.01e+1. In the year 1998, what is the difference between the Value added (current US$) in Manufacturing and Value added (current US$) in Agriculture?
Your response must be concise. 1.12e+1. In the year 1998, what is the difference between the Value added (current US$) in Services and Value added (current US$) in Agriculture?
Offer a very short reply. 2.13e+1. In the year 1999, what is the difference between the Value added (current US$) in Industry and Value added (current US$) in Manufacturing?
Provide a succinct answer. 1.23e+1. In the year 1999, what is the difference between the Value added (current US$) of Industry and Value added (current US$) of Services?
Offer a very short reply. 2.98e+09. In the year 1999, what is the difference between the Value added (current US$) in Industry and Value added (current US$) in Agriculture?
Keep it short and to the point. 2.82e+1. In the year 1999, what is the difference between the Value added (current US$) of Manufacturing and Value added (current US$) of Services?
Give a very brief answer. -9.31e+09. In the year 1999, what is the difference between the Value added (current US$) of Manufacturing and Value added (current US$) of Agriculture?
Offer a very short reply. 1.59e+1. In the year 1999, what is the difference between the Value added (current US$) in Services and Value added (current US$) in Agriculture?
Offer a terse response. 2.52e+1. In the year 2000, what is the difference between the Value added (current US$) of Industry and Value added (current US$) of Manufacturing?
Offer a very short reply. 1.64e+1. In the year 2000, what is the difference between the Value added (current US$) of Industry and Value added (current US$) of Services?
Offer a very short reply. 4.91e+09. In the year 2000, what is the difference between the Value added (current US$) of Industry and Value added (current US$) of Agriculture?
Your answer should be very brief. 3.73e+1. In the year 2000, what is the difference between the Value added (current US$) of Manufacturing and Value added (current US$) of Services?
Make the answer very short. -1.15e+1. In the year 2000, what is the difference between the Value added (current US$) of Manufacturing and Value added (current US$) of Agriculture?
Offer a very short reply. 2.09e+1. In the year 2000, what is the difference between the Value added (current US$) in Services and Value added (current US$) in Agriculture?
Provide a short and direct response. 3.23e+1. In the year 2001, what is the difference between the Value added (current US$) of Industry and Value added (current US$) of Manufacturing?
Provide a succinct answer. 1.56e+1. In the year 2001, what is the difference between the Value added (current US$) in Industry and Value added (current US$) in Services?
Keep it short and to the point. 3.88e+08. In the year 2001, what is the difference between the Value added (current US$) in Industry and Value added (current US$) in Agriculture?
Provide a succinct answer. 3.54e+1. In the year 2001, what is the difference between the Value added (current US$) in Manufacturing and Value added (current US$) in Services?
Offer a very short reply. -1.53e+1. In the year 2001, what is the difference between the Value added (current US$) of Manufacturing and Value added (current US$) of Agriculture?
Make the answer very short. 1.98e+1. In the year 2001, what is the difference between the Value added (current US$) of Services and Value added (current US$) of Agriculture?
Make the answer very short. 3.50e+1. In the year 2002, what is the difference between the Value added (current US$) in Industry and Value added (current US$) in Manufacturing?
Your answer should be compact. 1.60e+1. In the year 2002, what is the difference between the Value added (current US$) in Industry and Value added (current US$) in Services?
Ensure brevity in your answer.  -7.90e+08. In the year 2002, what is the difference between the Value added (current US$) of Industry and Value added (current US$) of Agriculture?
Offer a terse response. 3.64e+1. In the year 2002, what is the difference between the Value added (current US$) in Manufacturing and Value added (current US$) in Services?
Your answer should be very brief. -1.68e+1. In the year 2002, what is the difference between the Value added (current US$) in Manufacturing and Value added (current US$) in Agriculture?
Offer a very short reply. 2.04e+1. In the year 2002, what is the difference between the Value added (current US$) in Services and Value added (current US$) in Agriculture?
Provide a succinct answer. 3.72e+1. In the year 2003, what is the difference between the Value added (current US$) in Industry and Value added (current US$) in Manufacturing?
Your answer should be very brief. 1.83e+1. In the year 2003, what is the difference between the Value added (current US$) of Industry and Value added (current US$) of Services?
Offer a very short reply. 2.71e+09. In the year 2003, what is the difference between the Value added (current US$) in Industry and Value added (current US$) in Agriculture?
Your answer should be compact. 4.11e+1. In the year 2003, what is the difference between the Value added (current US$) in Manufacturing and Value added (current US$) in Services?
Ensure brevity in your answer.  -1.56e+1. In the year 2003, what is the difference between the Value added (current US$) in Manufacturing and Value added (current US$) in Agriculture?
Your response must be concise. 2.27e+1. In the year 2003, what is the difference between the Value added (current US$) of Services and Value added (current US$) of Agriculture?
Ensure brevity in your answer.  3.84e+1. What is the ratio of the Value added (current US$) of Industry in 1996 to that in 1997?
Provide a short and direct response. 0.98. What is the ratio of the Value added (current US$) in Manufacturing in 1996 to that in 1997?
Offer a very short reply. 0.99. What is the ratio of the Value added (current US$) of Services in 1996 to that in 1997?
Offer a very short reply. 1.02. What is the ratio of the Value added (current US$) of Agriculture in 1996 to that in 1997?
Ensure brevity in your answer.  1.06. What is the ratio of the Value added (current US$) in Industry in 1996 to that in 1998?
Your answer should be compact. 1.39. What is the ratio of the Value added (current US$) in Manufacturing in 1996 to that in 1998?
Provide a succinct answer. 1.35. What is the ratio of the Value added (current US$) in Services in 1996 to that in 1998?
Offer a terse response. 1.46. What is the ratio of the Value added (current US$) in Agriculture in 1996 to that in 1998?
Offer a very short reply. 1.23. What is the ratio of the Value added (current US$) of Industry in 1996 to that in 1999?
Your response must be concise. 1.19. What is the ratio of the Value added (current US$) in Manufacturing in 1996 to that in 1999?
Give a very brief answer. 1.15. What is the ratio of the Value added (current US$) of Services in 1996 to that in 1999?
Your response must be concise. 1.34. What is the ratio of the Value added (current US$) in Agriculture in 1996 to that in 1999?
Give a very brief answer. 1.37. What is the ratio of the Value added (current US$) in Industry in 1996 to that in 2000?
Ensure brevity in your answer.  0.97. What is the ratio of the Value added (current US$) in Manufacturing in 1996 to that in 2000?
Ensure brevity in your answer.  0.97. What is the ratio of the Value added (current US$) of Services in 1996 to that in 2000?
Ensure brevity in your answer.  1.12. What is the ratio of the Value added (current US$) of Agriculture in 1996 to that in 2000?
Give a very brief answer. 1.46. What is the ratio of the Value added (current US$) of Manufacturing in 1996 to that in 2001?
Your response must be concise. 1.03. What is the ratio of the Value added (current US$) in Services in 1996 to that in 2001?
Ensure brevity in your answer.  1.06. What is the ratio of the Value added (current US$) in Agriculture in 1996 to that in 2001?
Make the answer very short. 1.58. What is the ratio of the Value added (current US$) in Industry in 1996 to that in 2002?
Your answer should be very brief. 0.96. What is the ratio of the Value added (current US$) in Manufacturing in 1996 to that in 2002?
Your answer should be compact. 0.95. What is the ratio of the Value added (current US$) of Agriculture in 1996 to that in 2002?
Ensure brevity in your answer.  1.3. What is the ratio of the Value added (current US$) of Industry in 1996 to that in 2003?
Ensure brevity in your answer.  0.86. What is the ratio of the Value added (current US$) in Manufacturing in 1996 to that in 2003?
Your response must be concise. 0.85. What is the ratio of the Value added (current US$) of Services in 1996 to that in 2003?
Your answer should be very brief. 0.93. What is the ratio of the Value added (current US$) in Agriculture in 1996 to that in 2003?
Your response must be concise. 1.15. What is the ratio of the Value added (current US$) of Industry in 1997 to that in 1998?
Offer a terse response. 1.41. What is the ratio of the Value added (current US$) in Manufacturing in 1997 to that in 1998?
Make the answer very short. 1.37. What is the ratio of the Value added (current US$) of Services in 1997 to that in 1998?
Ensure brevity in your answer.  1.43. What is the ratio of the Value added (current US$) of Agriculture in 1997 to that in 1998?
Your answer should be compact. 1.16. What is the ratio of the Value added (current US$) in Industry in 1997 to that in 1999?
Ensure brevity in your answer.  1.21. What is the ratio of the Value added (current US$) in Manufacturing in 1997 to that in 1999?
Your answer should be compact. 1.16. What is the ratio of the Value added (current US$) of Services in 1997 to that in 1999?
Offer a very short reply. 1.31. What is the ratio of the Value added (current US$) in Agriculture in 1997 to that in 1999?
Provide a succinct answer. 1.29. What is the ratio of the Value added (current US$) in Industry in 1997 to that in 2000?
Make the answer very short. 0.98. What is the ratio of the Value added (current US$) in Manufacturing in 1997 to that in 2000?
Provide a succinct answer. 0.98. What is the ratio of the Value added (current US$) of Services in 1997 to that in 2000?
Your answer should be very brief. 1.1. What is the ratio of the Value added (current US$) of Agriculture in 1997 to that in 2000?
Your answer should be very brief. 1.38. What is the ratio of the Value added (current US$) in Industry in 1997 to that in 2001?
Offer a very short reply. 1.04. What is the ratio of the Value added (current US$) in Manufacturing in 1997 to that in 2001?
Give a very brief answer. 1.04. What is the ratio of the Value added (current US$) of Services in 1997 to that in 2001?
Your answer should be very brief. 1.04. What is the ratio of the Value added (current US$) of Agriculture in 1997 to that in 2001?
Give a very brief answer. 1.49. What is the ratio of the Value added (current US$) of Industry in 1997 to that in 2002?
Give a very brief answer. 0.98. What is the ratio of the Value added (current US$) of Manufacturing in 1997 to that in 2002?
Your response must be concise. 0.96. What is the ratio of the Value added (current US$) in Services in 1997 to that in 2002?
Make the answer very short. 0.96. What is the ratio of the Value added (current US$) in Agriculture in 1997 to that in 2002?
Provide a short and direct response. 1.23. What is the ratio of the Value added (current US$) of Industry in 1997 to that in 2003?
Offer a terse response. 0.87. What is the ratio of the Value added (current US$) of Manufacturing in 1997 to that in 2003?
Provide a succinct answer. 0.86. What is the ratio of the Value added (current US$) of Services in 1997 to that in 2003?
Keep it short and to the point. 0.91. What is the ratio of the Value added (current US$) in Agriculture in 1997 to that in 2003?
Provide a short and direct response. 1.08. What is the ratio of the Value added (current US$) of Industry in 1998 to that in 1999?
Give a very brief answer. 0.86. What is the ratio of the Value added (current US$) of Manufacturing in 1998 to that in 1999?
Offer a very short reply. 0.85. What is the ratio of the Value added (current US$) of Services in 1998 to that in 1999?
Make the answer very short. 0.91. What is the ratio of the Value added (current US$) of Agriculture in 1998 to that in 1999?
Offer a terse response. 1.12. What is the ratio of the Value added (current US$) in Industry in 1998 to that in 2000?
Ensure brevity in your answer.  0.7. What is the ratio of the Value added (current US$) of Manufacturing in 1998 to that in 2000?
Make the answer very short. 0.72. What is the ratio of the Value added (current US$) in Services in 1998 to that in 2000?
Your response must be concise. 0.76. What is the ratio of the Value added (current US$) of Agriculture in 1998 to that in 2000?
Your answer should be compact. 1.19. What is the ratio of the Value added (current US$) in Industry in 1998 to that in 2001?
Provide a succinct answer. 0.74. What is the ratio of the Value added (current US$) of Manufacturing in 1998 to that in 2001?
Provide a short and direct response. 0.76. What is the ratio of the Value added (current US$) in Services in 1998 to that in 2001?
Offer a very short reply. 0.73. What is the ratio of the Value added (current US$) of Agriculture in 1998 to that in 2001?
Provide a short and direct response. 1.29. What is the ratio of the Value added (current US$) in Industry in 1998 to that in 2002?
Provide a short and direct response. 0.7. What is the ratio of the Value added (current US$) of Manufacturing in 1998 to that in 2002?
Ensure brevity in your answer.  0.7. What is the ratio of the Value added (current US$) of Services in 1998 to that in 2002?
Offer a terse response. 0.67. What is the ratio of the Value added (current US$) of Agriculture in 1998 to that in 2002?
Offer a very short reply. 1.06. What is the ratio of the Value added (current US$) in Industry in 1998 to that in 2003?
Keep it short and to the point. 0.62. What is the ratio of the Value added (current US$) in Manufacturing in 1998 to that in 2003?
Provide a succinct answer. 0.63. What is the ratio of the Value added (current US$) in Services in 1998 to that in 2003?
Your response must be concise. 0.64. What is the ratio of the Value added (current US$) in Agriculture in 1998 to that in 2003?
Keep it short and to the point. 0.94. What is the ratio of the Value added (current US$) of Industry in 1999 to that in 2000?
Keep it short and to the point. 0.81. What is the ratio of the Value added (current US$) in Manufacturing in 1999 to that in 2000?
Provide a succinct answer. 0.85. What is the ratio of the Value added (current US$) in Services in 1999 to that in 2000?
Ensure brevity in your answer.  0.84. What is the ratio of the Value added (current US$) in Agriculture in 1999 to that in 2000?
Ensure brevity in your answer.  1.06. What is the ratio of the Value added (current US$) of Industry in 1999 to that in 2001?
Give a very brief answer. 0.86. What is the ratio of the Value added (current US$) in Manufacturing in 1999 to that in 2001?
Your response must be concise. 0.9. What is the ratio of the Value added (current US$) of Services in 1999 to that in 2001?
Your response must be concise. 0.8. What is the ratio of the Value added (current US$) of Agriculture in 1999 to that in 2001?
Your response must be concise. 1.15. What is the ratio of the Value added (current US$) in Industry in 1999 to that in 2002?
Your answer should be compact. 0.81. What is the ratio of the Value added (current US$) of Manufacturing in 1999 to that in 2002?
Keep it short and to the point. 0.83. What is the ratio of the Value added (current US$) in Services in 1999 to that in 2002?
Your answer should be compact. 0.73. What is the ratio of the Value added (current US$) of Agriculture in 1999 to that in 2002?
Offer a terse response. 0.95. What is the ratio of the Value added (current US$) of Industry in 1999 to that in 2003?
Provide a succinct answer. 0.72. What is the ratio of the Value added (current US$) of Manufacturing in 1999 to that in 2003?
Keep it short and to the point. 0.74. What is the ratio of the Value added (current US$) of Services in 1999 to that in 2003?
Your answer should be very brief. 0.7. What is the ratio of the Value added (current US$) in Agriculture in 1999 to that in 2003?
Offer a terse response. 0.84. What is the ratio of the Value added (current US$) of Industry in 2000 to that in 2001?
Your response must be concise. 1.06. What is the ratio of the Value added (current US$) in Manufacturing in 2000 to that in 2001?
Make the answer very short. 1.06. What is the ratio of the Value added (current US$) of Services in 2000 to that in 2001?
Your answer should be compact. 0.95. What is the ratio of the Value added (current US$) of Agriculture in 2000 to that in 2001?
Offer a terse response. 1.09. What is the ratio of the Value added (current US$) of Industry in 2000 to that in 2002?
Your response must be concise. 1. What is the ratio of the Value added (current US$) in Manufacturing in 2000 to that in 2002?
Offer a very short reply. 0.98. What is the ratio of the Value added (current US$) in Services in 2000 to that in 2002?
Ensure brevity in your answer.  0.87. What is the ratio of the Value added (current US$) of Agriculture in 2000 to that in 2002?
Provide a succinct answer. 0.89. What is the ratio of the Value added (current US$) of Industry in 2000 to that in 2003?
Make the answer very short. 0.88. What is the ratio of the Value added (current US$) in Manufacturing in 2000 to that in 2003?
Give a very brief answer. 0.88. What is the ratio of the Value added (current US$) in Services in 2000 to that in 2003?
Keep it short and to the point. 0.83. What is the ratio of the Value added (current US$) in Agriculture in 2000 to that in 2003?
Provide a succinct answer. 0.79. What is the ratio of the Value added (current US$) in Industry in 2001 to that in 2002?
Ensure brevity in your answer.  0.94. What is the ratio of the Value added (current US$) in Manufacturing in 2001 to that in 2002?
Make the answer very short. 0.92. What is the ratio of the Value added (current US$) in Services in 2001 to that in 2002?
Offer a terse response. 0.92. What is the ratio of the Value added (current US$) of Agriculture in 2001 to that in 2002?
Provide a succinct answer. 0.82. What is the ratio of the Value added (current US$) in Industry in 2001 to that in 2003?
Your answer should be compact. 0.84. What is the ratio of the Value added (current US$) in Manufacturing in 2001 to that in 2003?
Ensure brevity in your answer.  0.83. What is the ratio of the Value added (current US$) in Services in 2001 to that in 2003?
Your response must be concise. 0.87. What is the ratio of the Value added (current US$) of Agriculture in 2001 to that in 2003?
Your answer should be compact. 0.72. What is the ratio of the Value added (current US$) of Industry in 2002 to that in 2003?
Provide a succinct answer. 0.89. What is the ratio of the Value added (current US$) in Manufacturing in 2002 to that in 2003?
Give a very brief answer. 0.89. What is the ratio of the Value added (current US$) of Services in 2002 to that in 2003?
Provide a succinct answer. 0.95. What is the ratio of the Value added (current US$) in Agriculture in 2002 to that in 2003?
Ensure brevity in your answer.  0.88. What is the difference between the highest and the second highest Value added (current US$) in Industry?
Keep it short and to the point. 5.83e+09. What is the difference between the highest and the second highest Value added (current US$) of Manufacturing?
Your answer should be compact. 3.49e+09. What is the difference between the highest and the second highest Value added (current US$) in Services?
Ensure brevity in your answer.  2.33e+09. What is the difference between the highest and the second highest Value added (current US$) of Agriculture?
Provide a succinct answer. 6.78e+08. What is the difference between the highest and the lowest Value added (current US$) of Industry?
Keep it short and to the point. 1.97e+1. What is the difference between the highest and the lowest Value added (current US$) of Manufacturing?
Your answer should be compact. 1.22e+1. What is the difference between the highest and the lowest Value added (current US$) of Services?
Make the answer very short. 1.77e+1. What is the difference between the highest and the lowest Value added (current US$) in Agriculture?
Your answer should be very brief. 4.35e+09. 